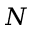Convert formula to latex. <formula><loc_0><loc_0><loc_500><loc_500>N</formula> 